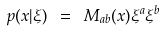<formula> <loc_0><loc_0><loc_500><loc_500>p ( x | \xi ) \ = \ M _ { a b } ( x ) \xi ^ { a } \xi ^ { b }</formula> 